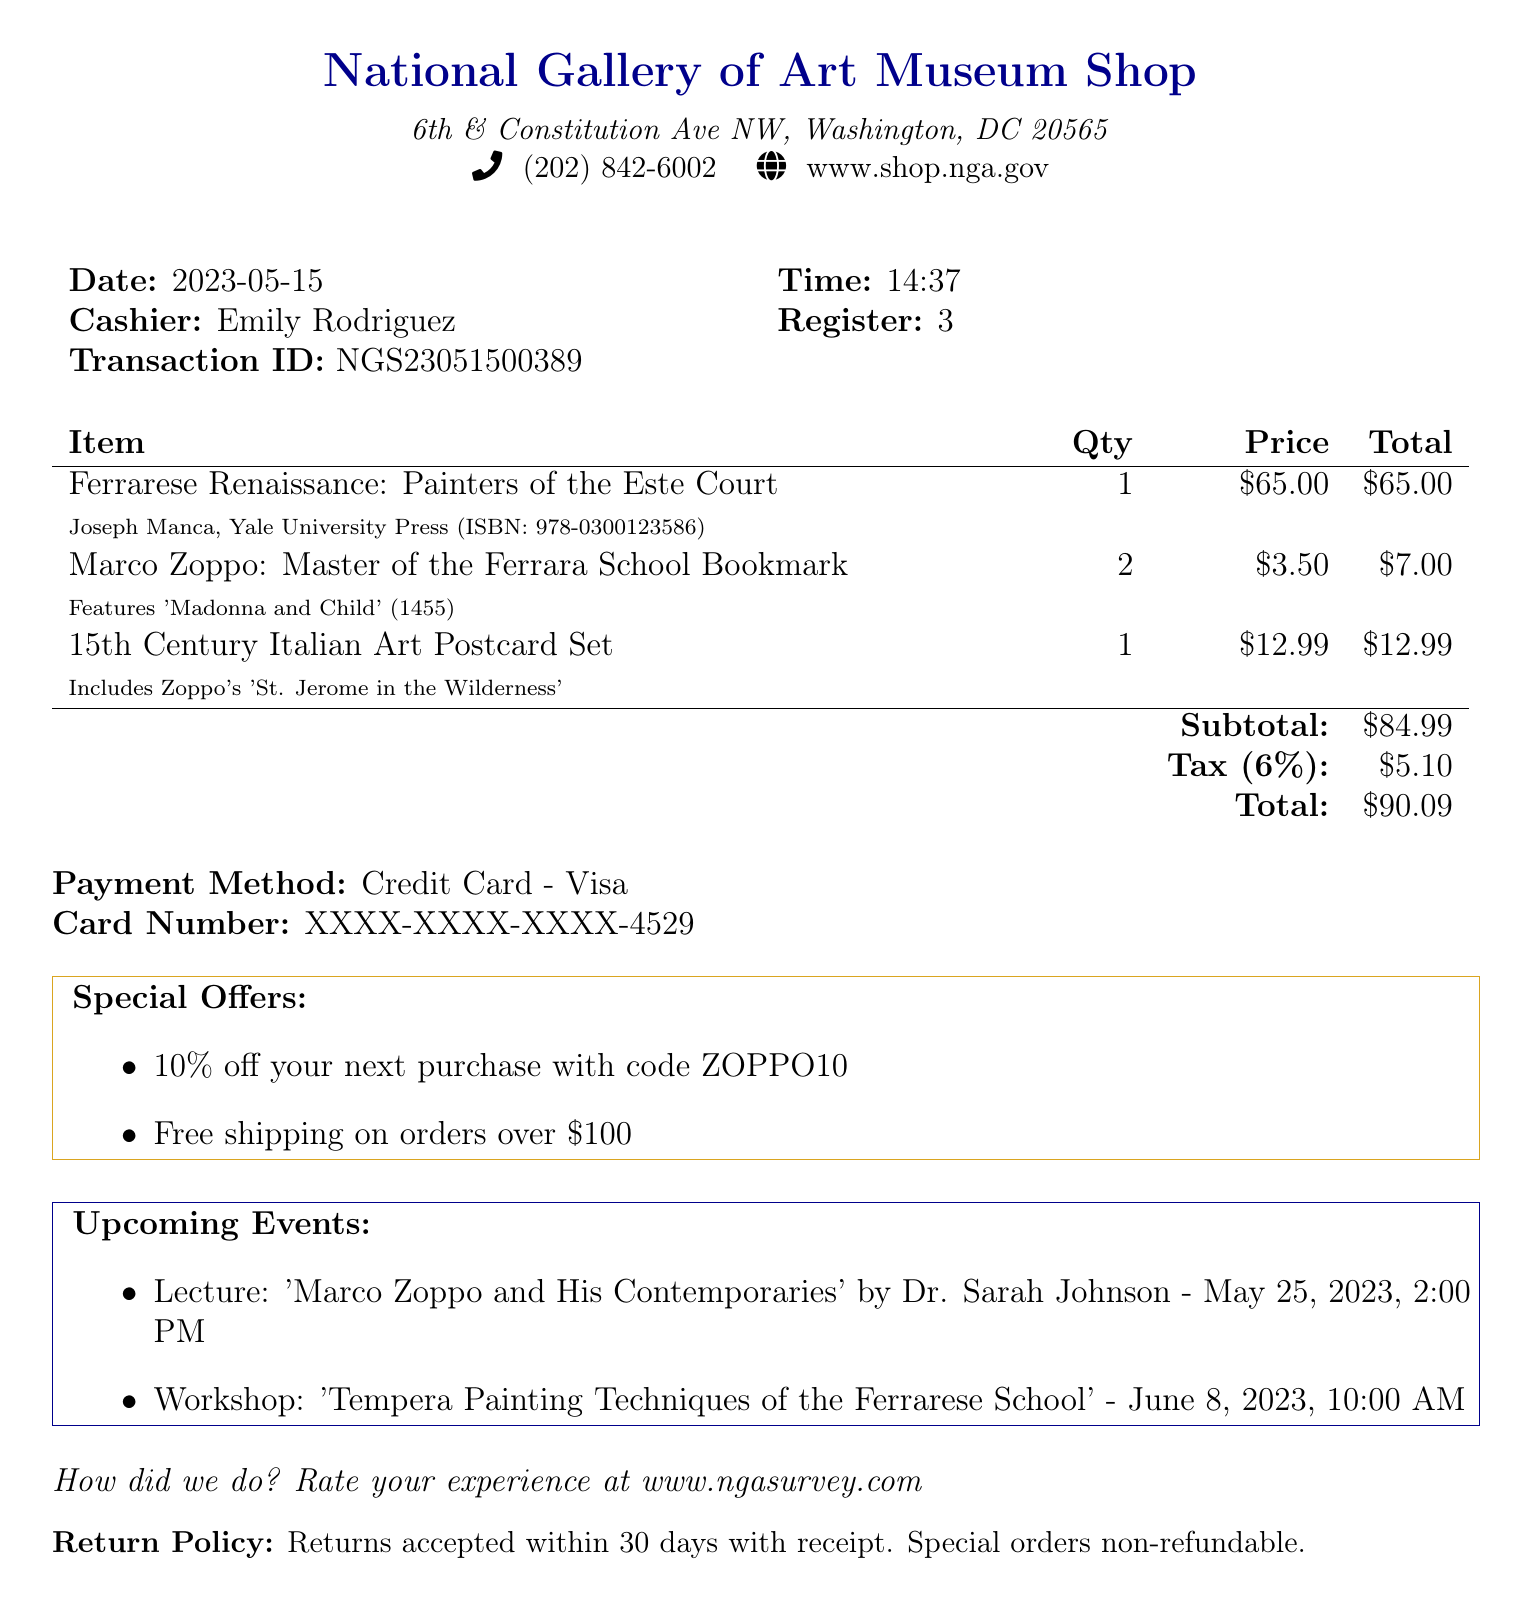what is the name of the book purchased? The name of the book is listed under items on the receipt.
Answer: Ferrarese Renaissance: Painters of the Este Court who is the author of the book? The author is mentioned in the item details of the receipt.
Answer: Joseph Manca what is the price of the bookmarks? The price for each bookmark is stated in the item section of the receipt.
Answer: 3.50 when was the transaction made? The date of the transaction is specified at the top of the receipt.
Answer: 2023-05-15 what is the total amount spent? The total amount is calculated by adding the subtotal and tax.
Answer: 90.09 how many bookmarks were purchased? The quantity of bookmarks purchased is indicated next to the item on the receipt.
Answer: 2 what is the special offer for the next purchase? The special offer is detailed in a specific section of the receipt.
Answer: 10% off your next purchase with code ZOPPO10 who is the cashier that processed the transaction? The cashier's name is displayed in the transaction details section of the receipt.
Answer: Emily Rodriguez what is the return policy stated in the document? The return policy is specified at the bottom of the receipt.
Answer: Returns accepted within 30 days with receipt. Special orders non-refundable 